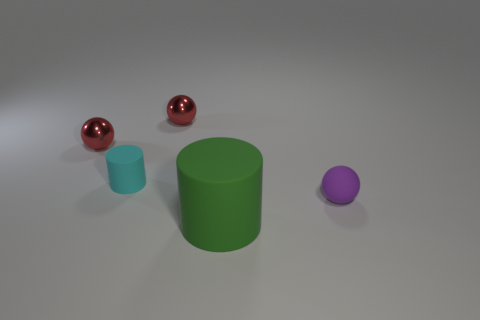Subtract all red balls. How many balls are left? 1 Subtract all balls. How many objects are left? 2 Subtract all purple balls. How many balls are left? 2 Add 3 blue shiny things. How many objects exist? 8 Subtract 0 purple cubes. How many objects are left? 5 Subtract 1 cylinders. How many cylinders are left? 1 Subtract all brown cylinders. Subtract all blue balls. How many cylinders are left? 2 Subtract all gray cubes. How many brown cylinders are left? 0 Subtract all big gray metallic objects. Subtract all metallic spheres. How many objects are left? 3 Add 3 small cyan rubber objects. How many small cyan rubber objects are left? 4 